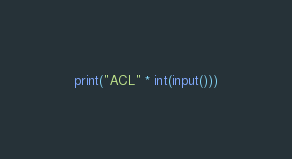Convert code to text. <code><loc_0><loc_0><loc_500><loc_500><_Python_>print("ACL" * int(input()))</code> 